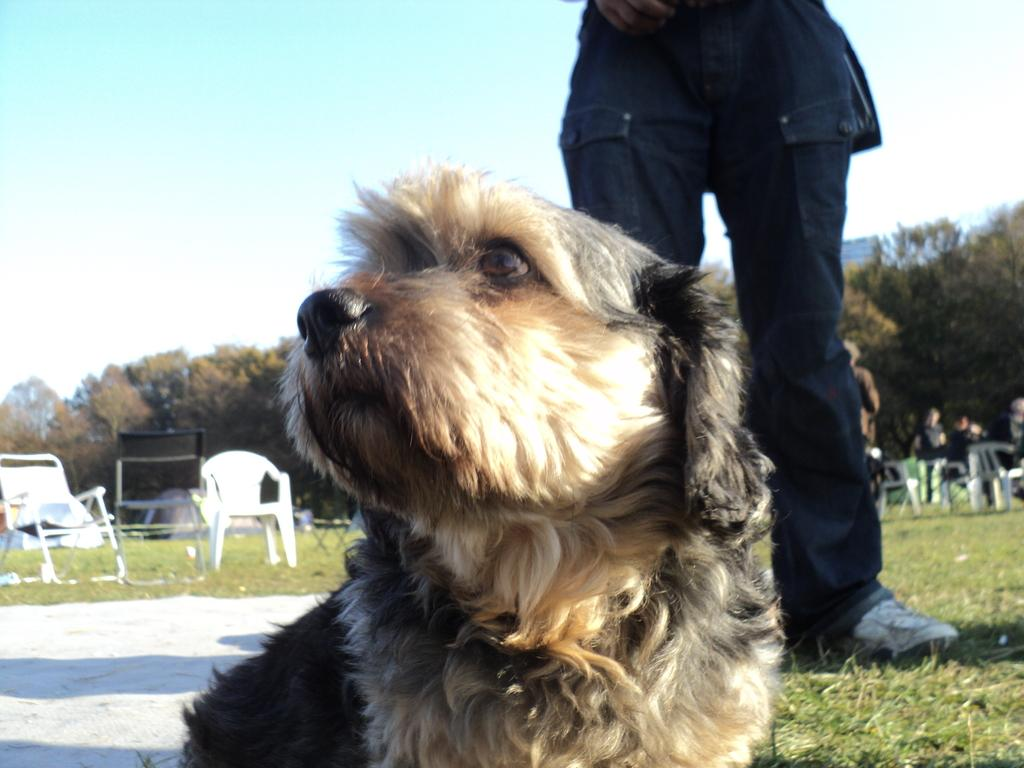What is the main subject in the foreground of the image? There is a dog in the foreground of the image. What is the person in the image doing? The person is standing on the grass. What objects can be seen in the background of the image? There are chairs and trees in the background of the image. What can be seen in the sky in the image? The sky is visible in the background of the image. What type of tax is being discussed by the dog and person in the image? There is no discussion of tax in the image, as it features a dog in the foreground and a person standing on the grass. 